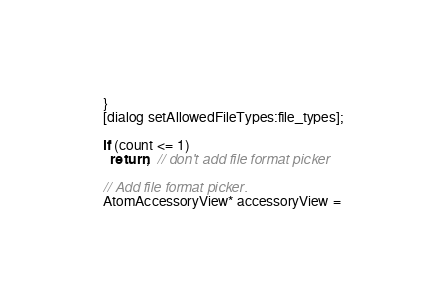<code> <loc_0><loc_0><loc_500><loc_500><_ObjectiveC_>  }
  [dialog setAllowedFileTypes:file_types];

  if (count <= 1)
    return;  // don't add file format picker

  // Add file format picker.
  AtomAccessoryView* accessoryView =</code> 